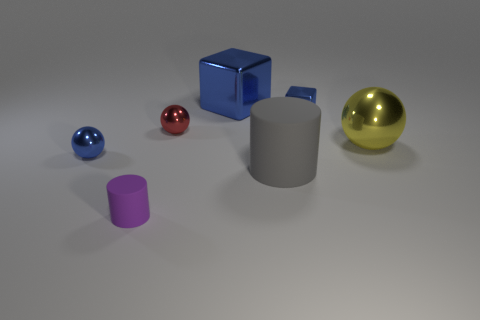Is the number of large metallic cubes less than the number of gray metal things?
Your answer should be compact. No. Does the small red shiny object have the same shape as the large blue object?
Offer a terse response. No. What number of objects are either large brown matte blocks or yellow objects that are in front of the large shiny block?
Make the answer very short. 1. How many tiny red things are there?
Provide a short and direct response. 1. Is there another rubber cylinder that has the same size as the gray matte cylinder?
Your response must be concise. No. Is the number of cubes that are right of the small shiny block less than the number of tiny things?
Your response must be concise. Yes. Do the yellow object and the purple thing have the same size?
Your response must be concise. No. What size is the red object that is made of the same material as the blue sphere?
Keep it short and to the point. Small. What number of metallic balls are the same color as the large rubber cylinder?
Give a very brief answer. 0. Are there fewer purple things that are in front of the blue shiny ball than blue balls that are right of the small metal block?
Your answer should be compact. No. 